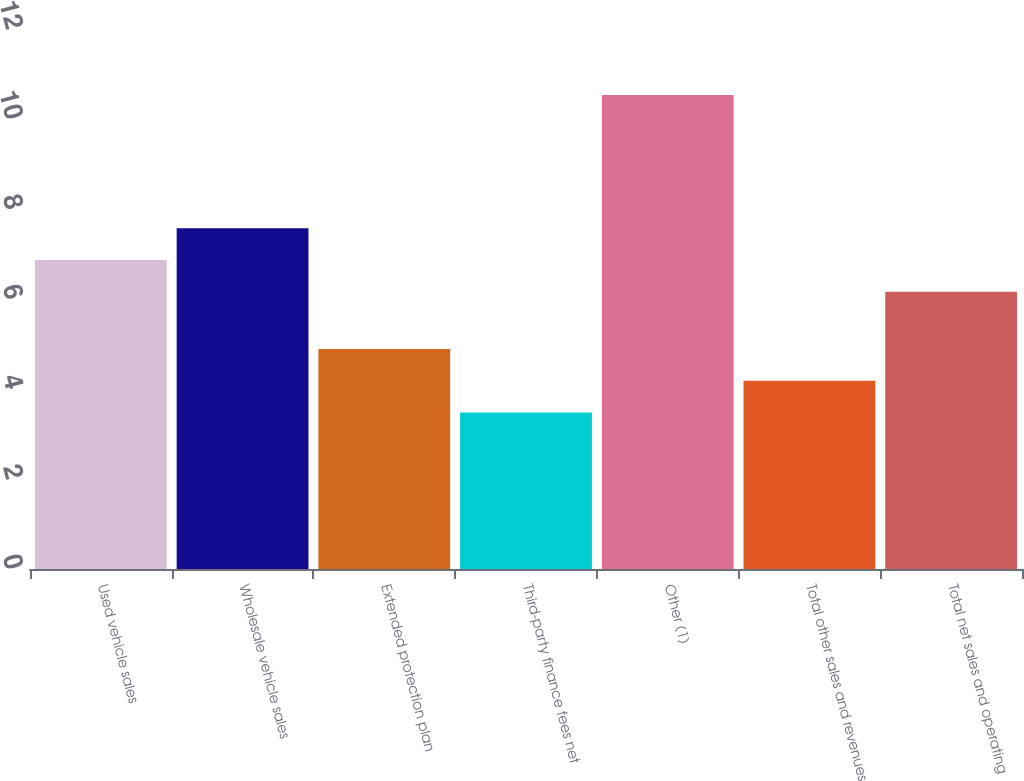Convert chart to OTSL. <chart><loc_0><loc_0><loc_500><loc_500><bar_chart><fcel>Used vehicle sales<fcel>Wholesale vehicle sales<fcel>Extended protection plan<fcel>Third-party finance fees net<fcel>Other (1)<fcel>Total other sales and revenues<fcel>Total net sales and operating<nl><fcel>6.91<fcel>7.62<fcel>4.92<fcel>3.5<fcel>10.6<fcel>4.21<fcel>6.2<nl></chart> 